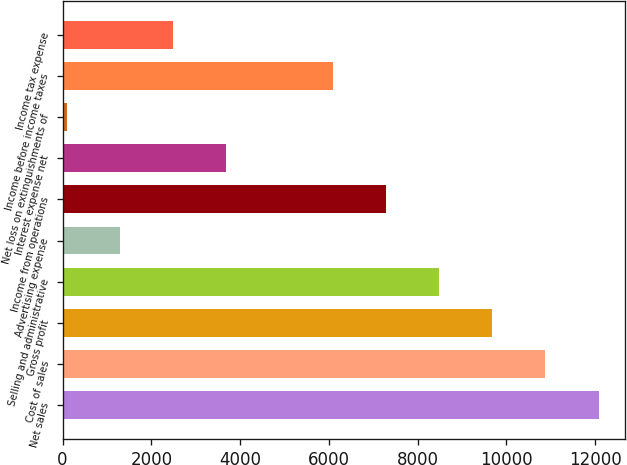Convert chart to OTSL. <chart><loc_0><loc_0><loc_500><loc_500><bar_chart><fcel>Net sales<fcel>Cost of sales<fcel>Gross profit<fcel>Selling and administrative<fcel>Advertising expense<fcel>Income from operations<fcel>Interest expense net<fcel>Net loss on extinguishments of<fcel>Income before income taxes<fcel>Income tax expense<nl><fcel>12074.5<fcel>10876.1<fcel>9677.74<fcel>8479.36<fcel>1289.08<fcel>7280.98<fcel>3685.84<fcel>90.7<fcel>6082.6<fcel>2487.46<nl></chart> 